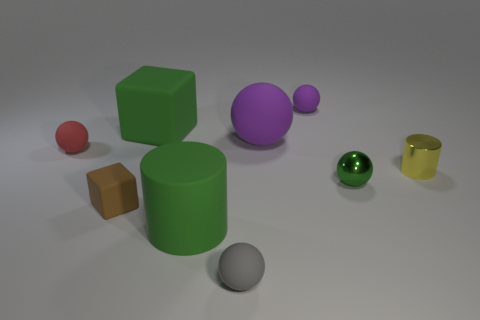There is a green matte object in front of the small red matte ball; does it have the same shape as the green object that is to the left of the big matte cylinder?
Ensure brevity in your answer.  No. There is a big thing that is in front of the big purple rubber ball that is on the right side of the tiny ball left of the gray object; what color is it?
Make the answer very short. Green. How many other objects are the same color as the tiny cylinder?
Make the answer very short. 0. Are there fewer large things than purple rubber spheres?
Give a very brief answer. No. There is a tiny object that is to the right of the rubber cylinder and behind the small yellow thing; what color is it?
Make the answer very short. Purple. What material is the tiny red object that is the same shape as the small green thing?
Your response must be concise. Rubber. Is the number of large cyan blocks greater than the number of brown matte cubes?
Provide a short and direct response. No. There is a sphere that is both in front of the red matte ball and behind the small gray object; how big is it?
Offer a terse response. Small. What shape is the tiny red object?
Offer a terse response. Sphere. How many tiny shiny things have the same shape as the tiny purple matte object?
Keep it short and to the point. 1. 